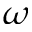<formula> <loc_0><loc_0><loc_500><loc_500>\omega</formula> 